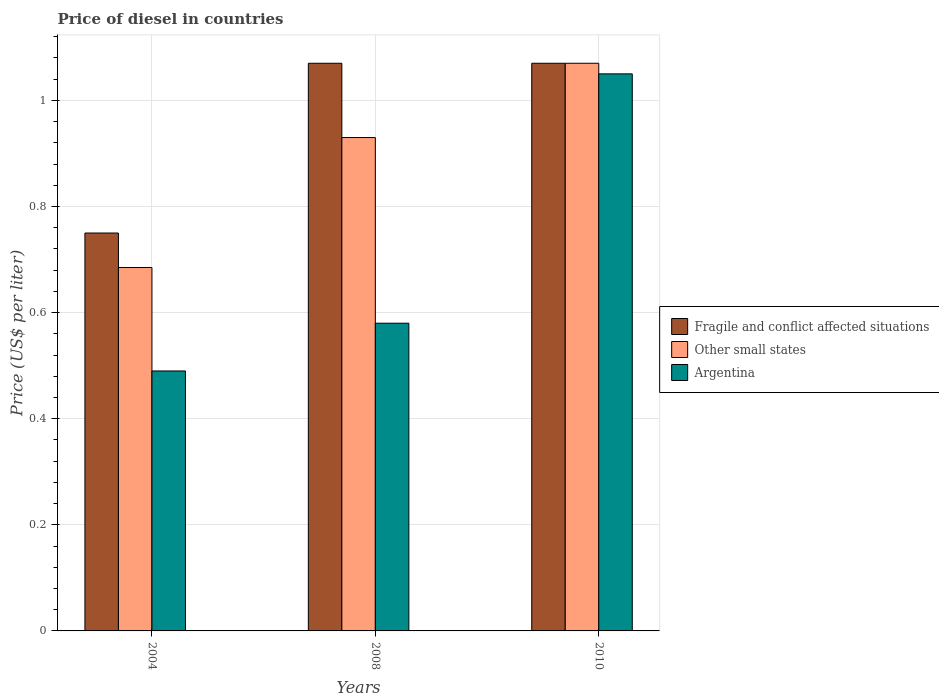How many groups of bars are there?
Provide a succinct answer. 3. What is the price of diesel in Fragile and conflict affected situations in 2010?
Provide a succinct answer. 1.07. Across all years, what is the minimum price of diesel in Fragile and conflict affected situations?
Make the answer very short. 0.75. What is the total price of diesel in Argentina in the graph?
Ensure brevity in your answer.  2.12. What is the difference between the price of diesel in Argentina in 2004 and that in 2008?
Your response must be concise. -0.09. What is the difference between the price of diesel in Other small states in 2008 and the price of diesel in Fragile and conflict affected situations in 2004?
Provide a succinct answer. 0.18. What is the average price of diesel in Argentina per year?
Provide a short and direct response. 0.71. In the year 2008, what is the difference between the price of diesel in Other small states and price of diesel in Argentina?
Your answer should be very brief. 0.35. What is the ratio of the price of diesel in Other small states in 2004 to that in 2010?
Provide a short and direct response. 0.64. Is the price of diesel in Other small states in 2004 less than that in 2008?
Ensure brevity in your answer.  Yes. Is the difference between the price of diesel in Other small states in 2004 and 2008 greater than the difference between the price of diesel in Argentina in 2004 and 2008?
Your response must be concise. No. What is the difference between the highest and the lowest price of diesel in Argentina?
Provide a succinct answer. 0.56. What does the 1st bar from the left in 2004 represents?
Your answer should be very brief. Fragile and conflict affected situations. What does the 3rd bar from the right in 2008 represents?
Ensure brevity in your answer.  Fragile and conflict affected situations. How many bars are there?
Offer a very short reply. 9. Are all the bars in the graph horizontal?
Keep it short and to the point. No. Are the values on the major ticks of Y-axis written in scientific E-notation?
Make the answer very short. No. How are the legend labels stacked?
Give a very brief answer. Vertical. What is the title of the graph?
Keep it short and to the point. Price of diesel in countries. What is the label or title of the Y-axis?
Your answer should be compact. Price (US$ per liter). What is the Price (US$ per liter) of Other small states in 2004?
Provide a succinct answer. 0.69. What is the Price (US$ per liter) of Argentina in 2004?
Offer a very short reply. 0.49. What is the Price (US$ per liter) in Fragile and conflict affected situations in 2008?
Offer a very short reply. 1.07. What is the Price (US$ per liter) in Other small states in 2008?
Your response must be concise. 0.93. What is the Price (US$ per liter) of Argentina in 2008?
Ensure brevity in your answer.  0.58. What is the Price (US$ per liter) in Fragile and conflict affected situations in 2010?
Offer a terse response. 1.07. What is the Price (US$ per liter) of Other small states in 2010?
Offer a terse response. 1.07. Across all years, what is the maximum Price (US$ per liter) in Fragile and conflict affected situations?
Provide a short and direct response. 1.07. Across all years, what is the maximum Price (US$ per liter) in Other small states?
Offer a very short reply. 1.07. Across all years, what is the minimum Price (US$ per liter) in Other small states?
Give a very brief answer. 0.69. Across all years, what is the minimum Price (US$ per liter) in Argentina?
Your answer should be compact. 0.49. What is the total Price (US$ per liter) of Fragile and conflict affected situations in the graph?
Provide a short and direct response. 2.89. What is the total Price (US$ per liter) in Other small states in the graph?
Your answer should be compact. 2.69. What is the total Price (US$ per liter) of Argentina in the graph?
Offer a very short reply. 2.12. What is the difference between the Price (US$ per liter) of Fragile and conflict affected situations in 2004 and that in 2008?
Ensure brevity in your answer.  -0.32. What is the difference between the Price (US$ per liter) of Other small states in 2004 and that in 2008?
Give a very brief answer. -0.24. What is the difference between the Price (US$ per liter) in Argentina in 2004 and that in 2008?
Offer a very short reply. -0.09. What is the difference between the Price (US$ per liter) of Fragile and conflict affected situations in 2004 and that in 2010?
Make the answer very short. -0.32. What is the difference between the Price (US$ per liter) of Other small states in 2004 and that in 2010?
Provide a succinct answer. -0.39. What is the difference between the Price (US$ per liter) of Argentina in 2004 and that in 2010?
Make the answer very short. -0.56. What is the difference between the Price (US$ per liter) in Other small states in 2008 and that in 2010?
Provide a succinct answer. -0.14. What is the difference between the Price (US$ per liter) in Argentina in 2008 and that in 2010?
Provide a succinct answer. -0.47. What is the difference between the Price (US$ per liter) of Fragile and conflict affected situations in 2004 and the Price (US$ per liter) of Other small states in 2008?
Your answer should be compact. -0.18. What is the difference between the Price (US$ per liter) of Fragile and conflict affected situations in 2004 and the Price (US$ per liter) of Argentina in 2008?
Make the answer very short. 0.17. What is the difference between the Price (US$ per liter) in Other small states in 2004 and the Price (US$ per liter) in Argentina in 2008?
Your answer should be compact. 0.1. What is the difference between the Price (US$ per liter) in Fragile and conflict affected situations in 2004 and the Price (US$ per liter) in Other small states in 2010?
Make the answer very short. -0.32. What is the difference between the Price (US$ per liter) of Fragile and conflict affected situations in 2004 and the Price (US$ per liter) of Argentina in 2010?
Ensure brevity in your answer.  -0.3. What is the difference between the Price (US$ per liter) of Other small states in 2004 and the Price (US$ per liter) of Argentina in 2010?
Provide a succinct answer. -0.36. What is the difference between the Price (US$ per liter) in Other small states in 2008 and the Price (US$ per liter) in Argentina in 2010?
Provide a short and direct response. -0.12. What is the average Price (US$ per liter) of Fragile and conflict affected situations per year?
Your response must be concise. 0.96. What is the average Price (US$ per liter) in Other small states per year?
Offer a very short reply. 0.9. What is the average Price (US$ per liter) of Argentina per year?
Give a very brief answer. 0.71. In the year 2004, what is the difference between the Price (US$ per liter) in Fragile and conflict affected situations and Price (US$ per liter) in Other small states?
Make the answer very short. 0.07. In the year 2004, what is the difference between the Price (US$ per liter) in Fragile and conflict affected situations and Price (US$ per liter) in Argentina?
Your response must be concise. 0.26. In the year 2004, what is the difference between the Price (US$ per liter) of Other small states and Price (US$ per liter) of Argentina?
Offer a terse response. 0.2. In the year 2008, what is the difference between the Price (US$ per liter) in Fragile and conflict affected situations and Price (US$ per liter) in Other small states?
Your response must be concise. 0.14. In the year 2008, what is the difference between the Price (US$ per liter) in Fragile and conflict affected situations and Price (US$ per liter) in Argentina?
Make the answer very short. 0.49. In the year 2008, what is the difference between the Price (US$ per liter) of Other small states and Price (US$ per liter) of Argentina?
Make the answer very short. 0.35. In the year 2010, what is the difference between the Price (US$ per liter) in Fragile and conflict affected situations and Price (US$ per liter) in Argentina?
Offer a very short reply. 0.02. What is the ratio of the Price (US$ per liter) of Fragile and conflict affected situations in 2004 to that in 2008?
Your answer should be compact. 0.7. What is the ratio of the Price (US$ per liter) of Other small states in 2004 to that in 2008?
Give a very brief answer. 0.74. What is the ratio of the Price (US$ per liter) of Argentina in 2004 to that in 2008?
Keep it short and to the point. 0.84. What is the ratio of the Price (US$ per liter) in Fragile and conflict affected situations in 2004 to that in 2010?
Your answer should be compact. 0.7. What is the ratio of the Price (US$ per liter) in Other small states in 2004 to that in 2010?
Provide a short and direct response. 0.64. What is the ratio of the Price (US$ per liter) of Argentina in 2004 to that in 2010?
Your answer should be very brief. 0.47. What is the ratio of the Price (US$ per liter) of Fragile and conflict affected situations in 2008 to that in 2010?
Your answer should be very brief. 1. What is the ratio of the Price (US$ per liter) in Other small states in 2008 to that in 2010?
Provide a short and direct response. 0.87. What is the ratio of the Price (US$ per liter) of Argentina in 2008 to that in 2010?
Offer a terse response. 0.55. What is the difference between the highest and the second highest Price (US$ per liter) of Other small states?
Make the answer very short. 0.14. What is the difference between the highest and the second highest Price (US$ per liter) in Argentina?
Make the answer very short. 0.47. What is the difference between the highest and the lowest Price (US$ per liter) of Fragile and conflict affected situations?
Give a very brief answer. 0.32. What is the difference between the highest and the lowest Price (US$ per liter) in Other small states?
Provide a short and direct response. 0.39. What is the difference between the highest and the lowest Price (US$ per liter) of Argentina?
Give a very brief answer. 0.56. 